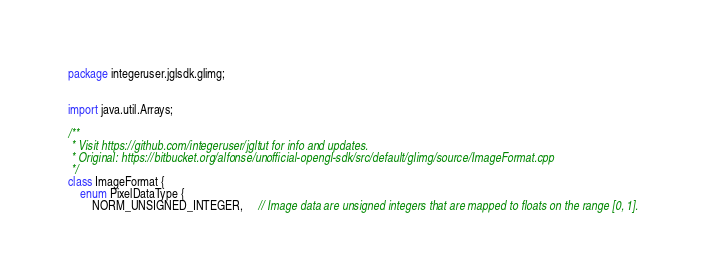Convert code to text. <code><loc_0><loc_0><loc_500><loc_500><_Java_>package integeruser.jglsdk.glimg;


import java.util.Arrays;

/**
 * Visit https://github.com/integeruser/jgltut for info and updates.
 * Original: https://bitbucket.org/alfonse/unofficial-opengl-sdk/src/default/glimg/source/ImageFormat.cpp
 */
class ImageFormat {
    enum PixelDataType {
        NORM_UNSIGNED_INTEGER,     // Image data are unsigned integers that are mapped to floats on the range [0, 1].</code> 